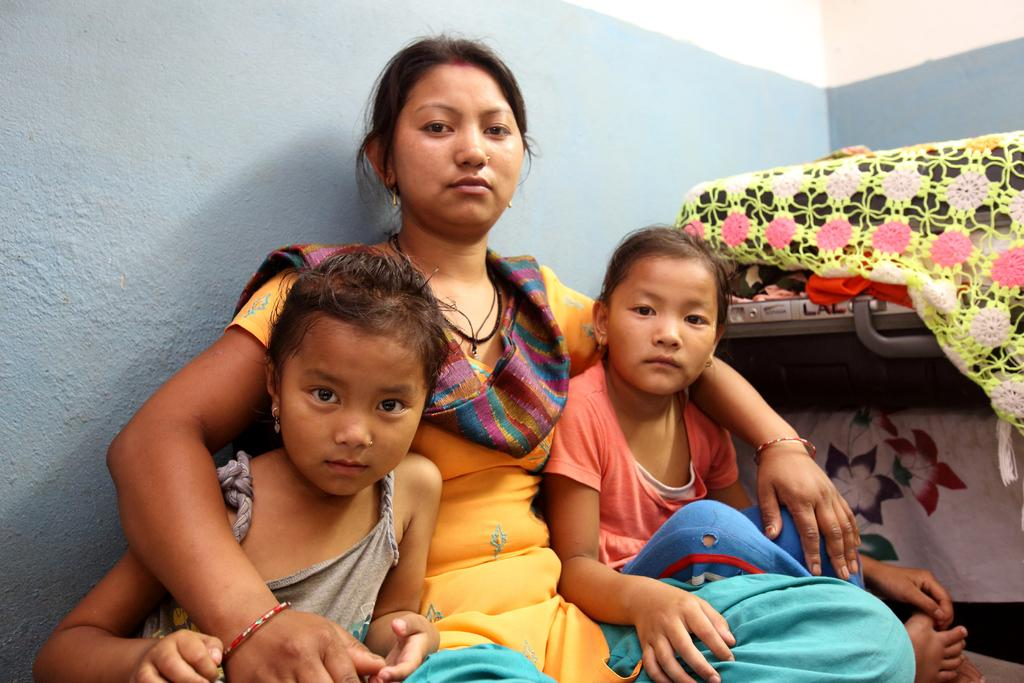Who is the main subject in the image? There is a lady in the image. Are there any other people in the image? Yes, there are two children in the image. Where are the lady and children located in the image? The lady and children are in the center of the image. What can be seen on the right side of the image? There are suitcases on the right side of the image. What type of spark can be seen between the lady and the children in the image? There is no spark visible between the lady and the children in the image. What kind of drug is being used by the lady in the image? There is no drug present in the image; it features a lady and two children in the center with suitcases on the right side. 